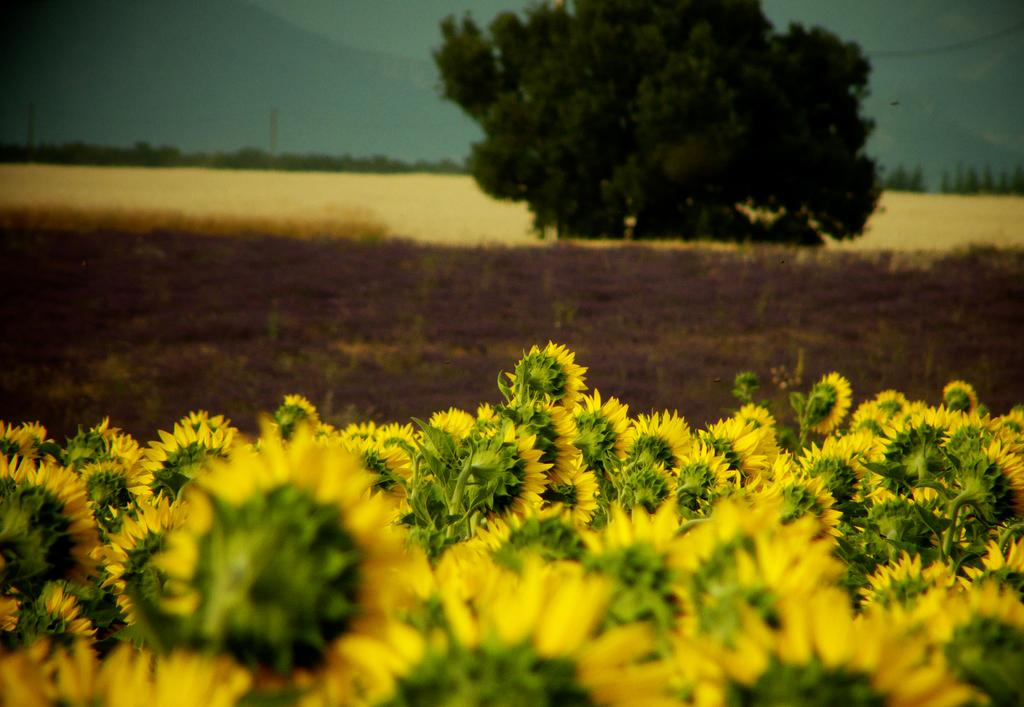What type of flowers are on the ground in the image? There are sunflowers on the ground in the image. What is the condition of the land in the image? The land is covered with mud in the image. What can be seen in the background of the image? There is a tree visible in the background of the image. How many bikes are parked near the tree in the image? There are no bikes present in the image. Can you hear the sound of the sunflowers rustling in the image? The image is a still photograph and does not contain any sound, so it is not possible to hear the sunflowers rustling. 